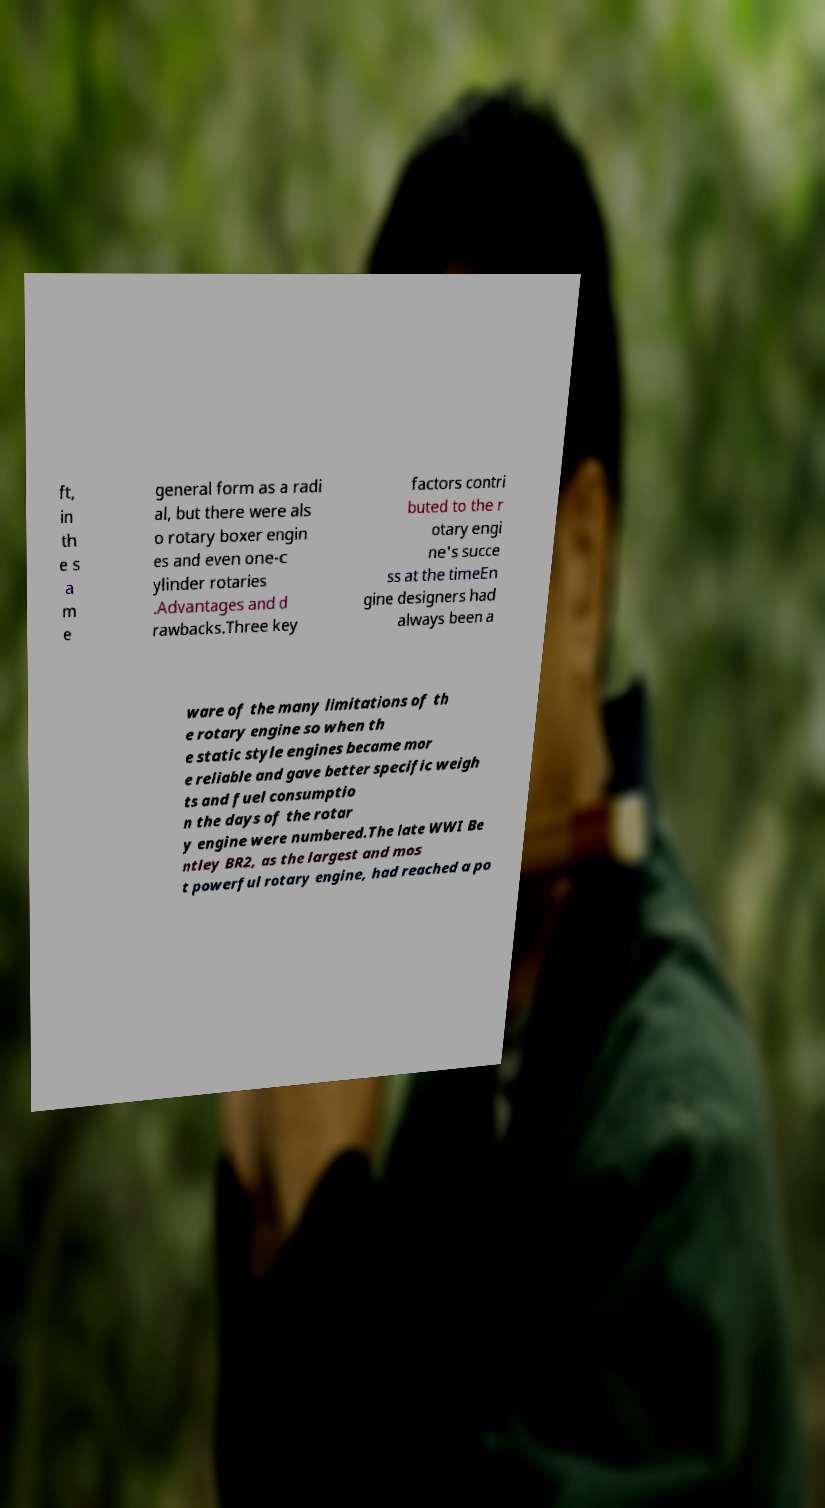Please read and relay the text visible in this image. What does it say? ft, in th e s a m e general form as a radi al, but there were als o rotary boxer engin es and even one-c ylinder rotaries .Advantages and d rawbacks.Three key factors contri buted to the r otary engi ne's succe ss at the timeEn gine designers had always been a ware of the many limitations of th e rotary engine so when th e static style engines became mor e reliable and gave better specific weigh ts and fuel consumptio n the days of the rotar y engine were numbered.The late WWI Be ntley BR2, as the largest and mos t powerful rotary engine, had reached a po 